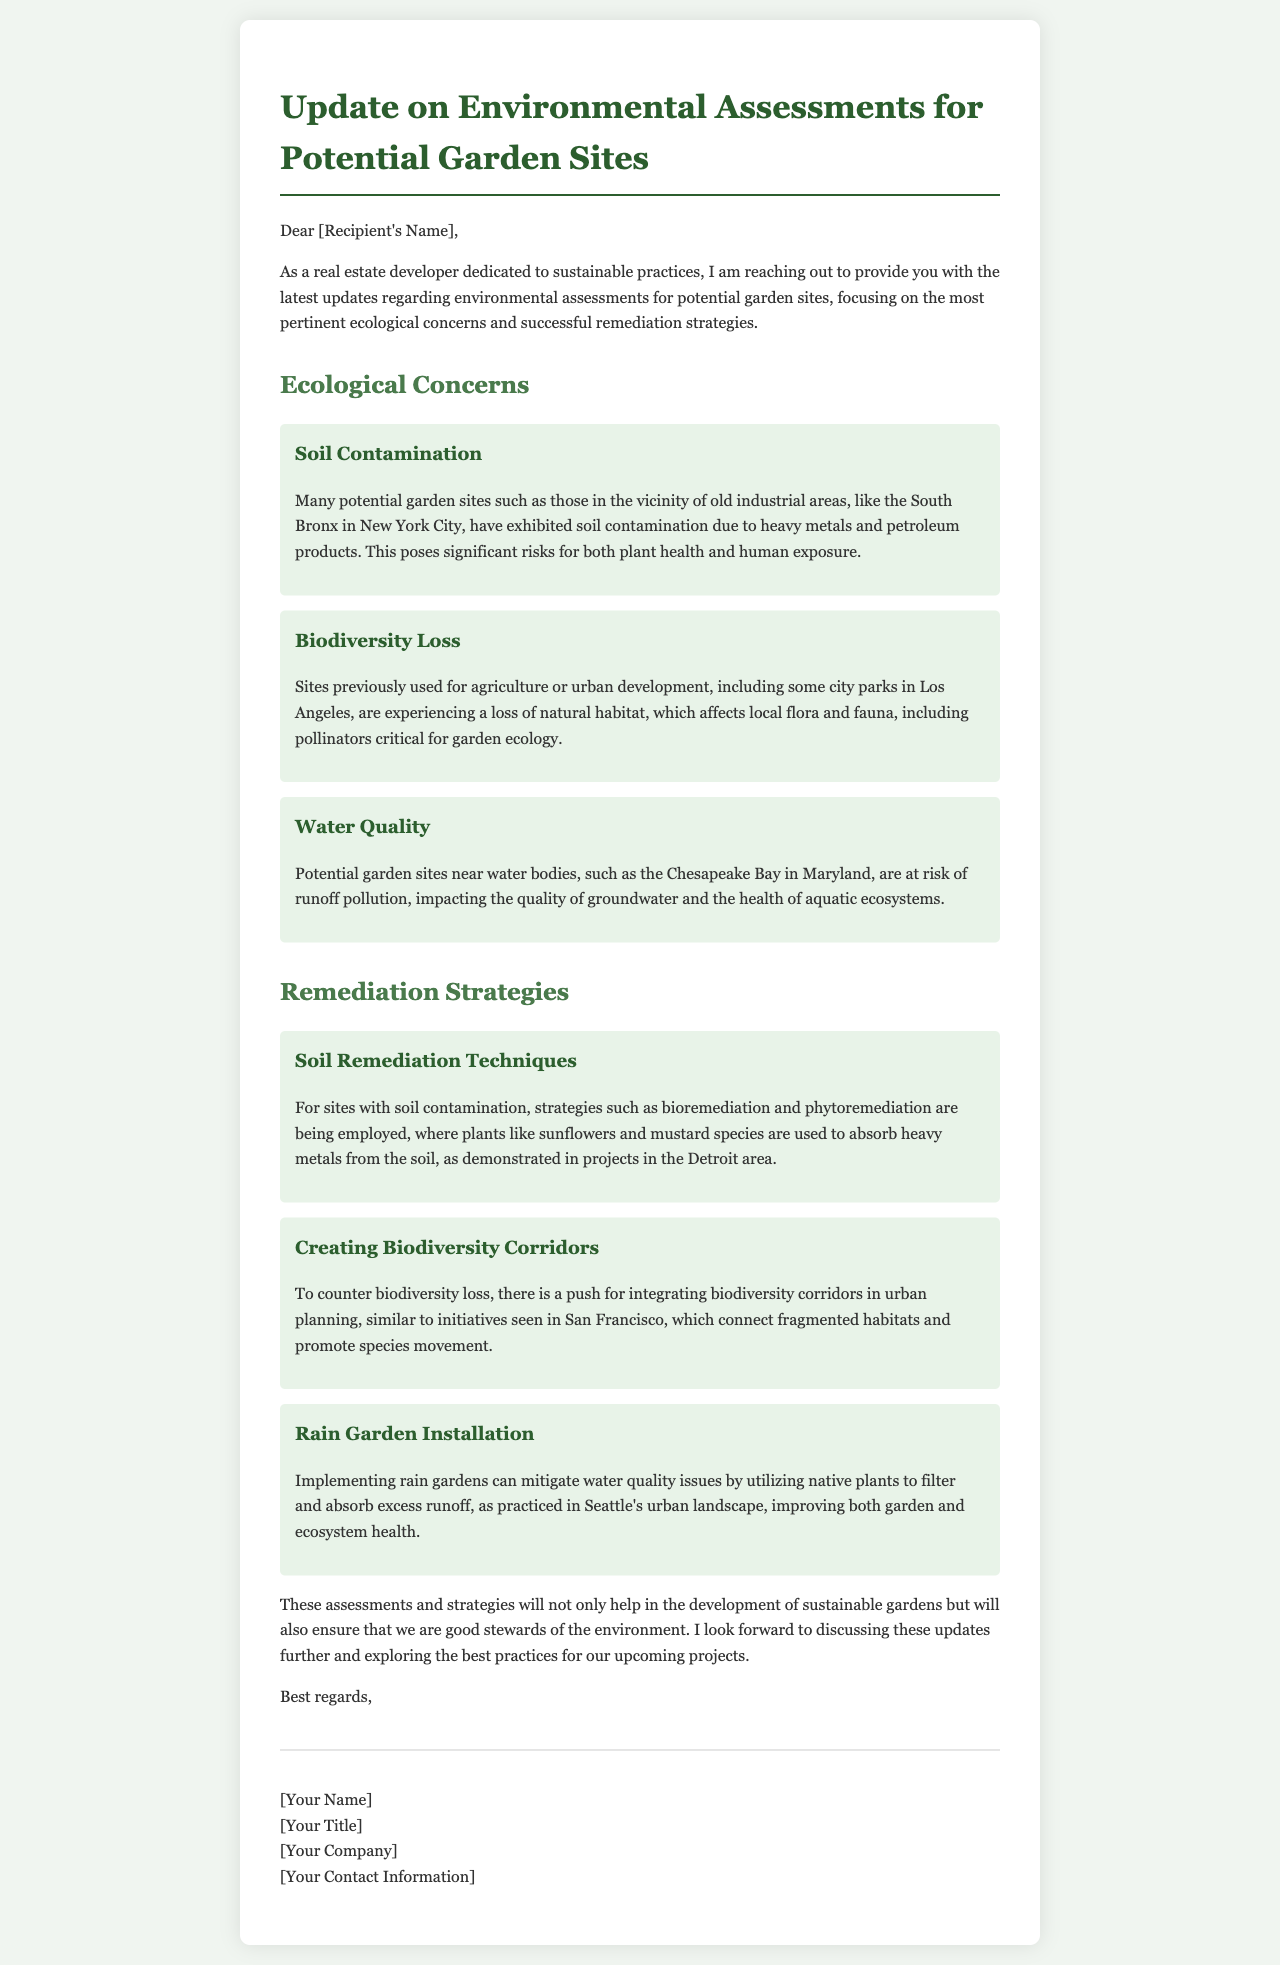What is the title of the document? The title of the document is presented at the beginning, which serves as the subject of the letter.
Answer: Update on Environmental Assessments for Potential Garden Sites Who is the sender of the letter? The sender's name is included at the end of the letter in the signature section.
Answer: [Your Name] What is a major ecological concern mentioned in the document? The document lists specific ecological concerns under the "Ecological Concerns" section, presenting critical issues.
Answer: Soil Contamination Which remediation strategy uses native plants? The various strategies for remediation include specific actions to address ecological concerns, highlighting the use of native plants.
Answer: Rain Garden Installation Where is the water quality issue noted? The document specifies a location related to the water quality concern in the context of potential garden sites.
Answer: Chesapeake Bay in Maryland What technique is mentioned for soil remediation? The document provides particular techniques used for addressing soil contamination, which are relevant to project planning.
Answer: Bioremediation How does the document suggest improving biodiversity? There are specific strategies recommended for enhancing biodiversity in garden sites outlined in the document.
Answer: Creating Biodiversity Corridors What city is referenced for its rain garden practices? A city known for its implementation of rain gardens is mentioned in the context of successful remediation strategies.
Answer: Seattle What is the overall purpose of the letter? The main intent behind the letter is expressed in the introductory section, emphasizing the sender's commitment.
Answer: Provide updates on environmental assessments 